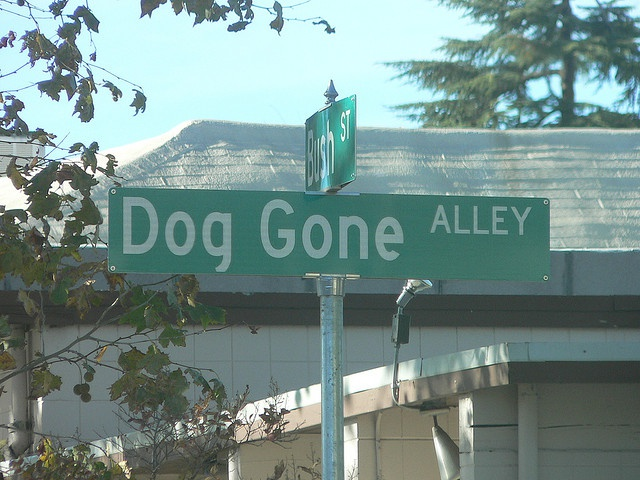Describe the objects in this image and their specific colors. I can see various objects in this image with different colors. 